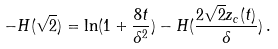Convert formula to latex. <formula><loc_0><loc_0><loc_500><loc_500>- H ( \sqrt { 2 } ) = \ln ( 1 + \frac { 8 t } { \delta ^ { 2 } } ) - H ( \frac { 2 \sqrt { 2 } z _ { c } ( t ) } { \delta } ) \, .</formula> 